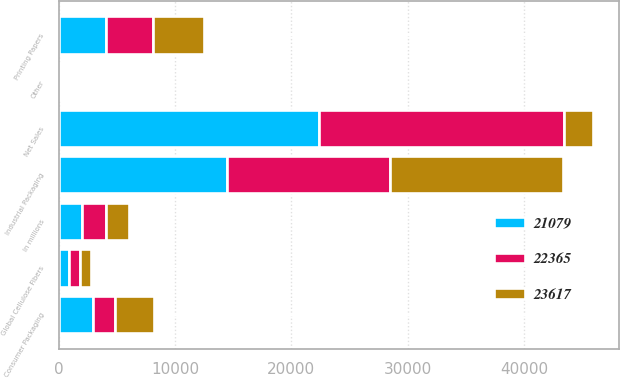<chart> <loc_0><loc_0><loc_500><loc_500><stacked_bar_chart><ecel><fcel>In millions<fcel>Industrial Packaging<fcel>Global Cellulose Fibers<fcel>Printing Papers<fcel>Consumer Packaging<fcel>Other<fcel>Net Sales<nl><fcel>22365<fcel>2016<fcel>14095<fcel>934<fcel>4028<fcel>1934<fcel>88<fcel>21079<nl><fcel>21079<fcel>2015<fcel>14421<fcel>873<fcel>4046<fcel>2907<fcel>118<fcel>22365<nl><fcel>23617<fcel>2014<fcel>14837<fcel>947<fcel>4413<fcel>3307<fcel>113<fcel>2461.5<nl></chart> 